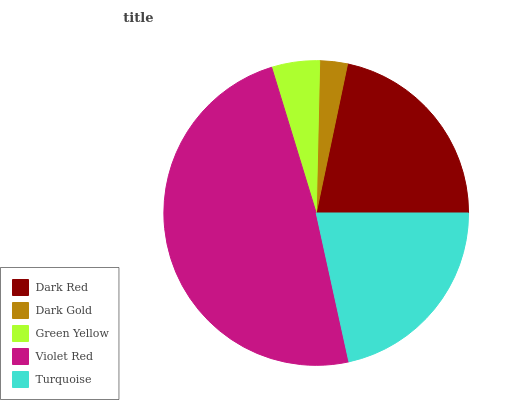Is Dark Gold the minimum?
Answer yes or no. Yes. Is Violet Red the maximum?
Answer yes or no. Yes. Is Green Yellow the minimum?
Answer yes or no. No. Is Green Yellow the maximum?
Answer yes or no. No. Is Green Yellow greater than Dark Gold?
Answer yes or no. Yes. Is Dark Gold less than Green Yellow?
Answer yes or no. Yes. Is Dark Gold greater than Green Yellow?
Answer yes or no. No. Is Green Yellow less than Dark Gold?
Answer yes or no. No. Is Turquoise the high median?
Answer yes or no. Yes. Is Turquoise the low median?
Answer yes or no. Yes. Is Dark Gold the high median?
Answer yes or no. No. Is Violet Red the low median?
Answer yes or no. No. 